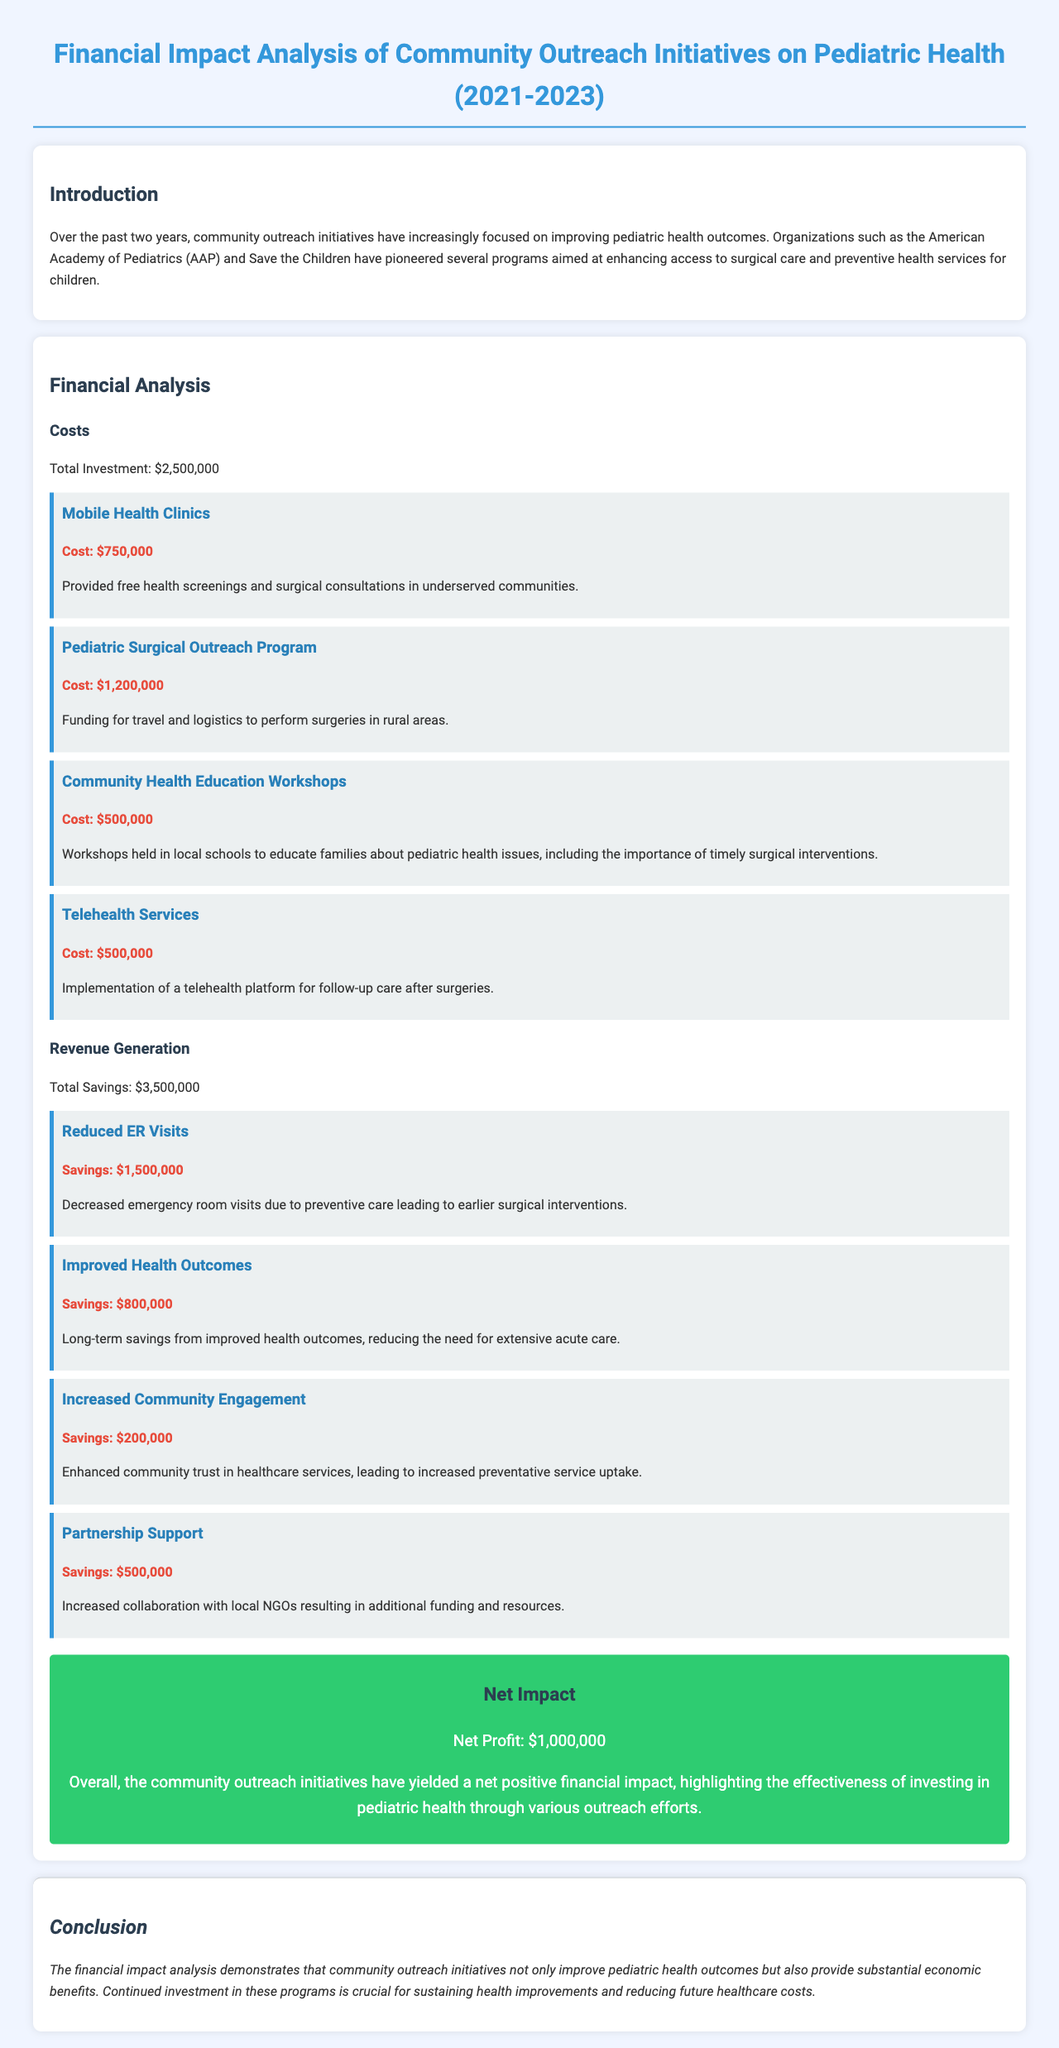what is the total investment? The total investment is explicitly stated in the document under the financial analysis section.
Answer: $2,500,000 how much did the Pediatric Surgical Outreach Program cost? The document provides the cost for each program under the financial analysis section.
Answer: $1,200,000 what was the savings from reduced ER visits? The savings from reduced ER visits is mentioned in the document, specifically in the revenue generation section.
Answer: $1,500,000 what is the net profit from the community outreach initiatives? The net profit is summarized in the net impact box within the financial analysis section.
Answer: $1,000,000 which program cost $500,000? The document lists different programs along with their costs; two programs are identified at that cost.
Answer: Telehealth Services what are the benefits of increased community engagement? The document elaborates on the benefits of increased community engagement within the revenue generation section.
Answer: $200,000 how much did the community health education workshops cost? The cost is provided alongside the description of the workshops in the financial analysis section.
Answer: $500,000 what is the total savings reported in the document? The total savings is calculated by summing all the savings listed in the revenue generation section.
Answer: $3,500,000 what does the conclusion emphasize about the community outreach initiatives? The conclusion section states the overall impact of the initiatives on both health outcomes and financial benefits.
Answer: Continued investment is crucial 